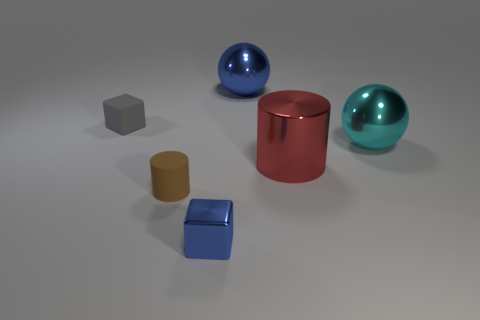Are any two objects in the image identical? No, there are no two objects in the image that are identical. Each object has a distinct shape, color, and size, contributing to a diverse collection of forms within the scene. 